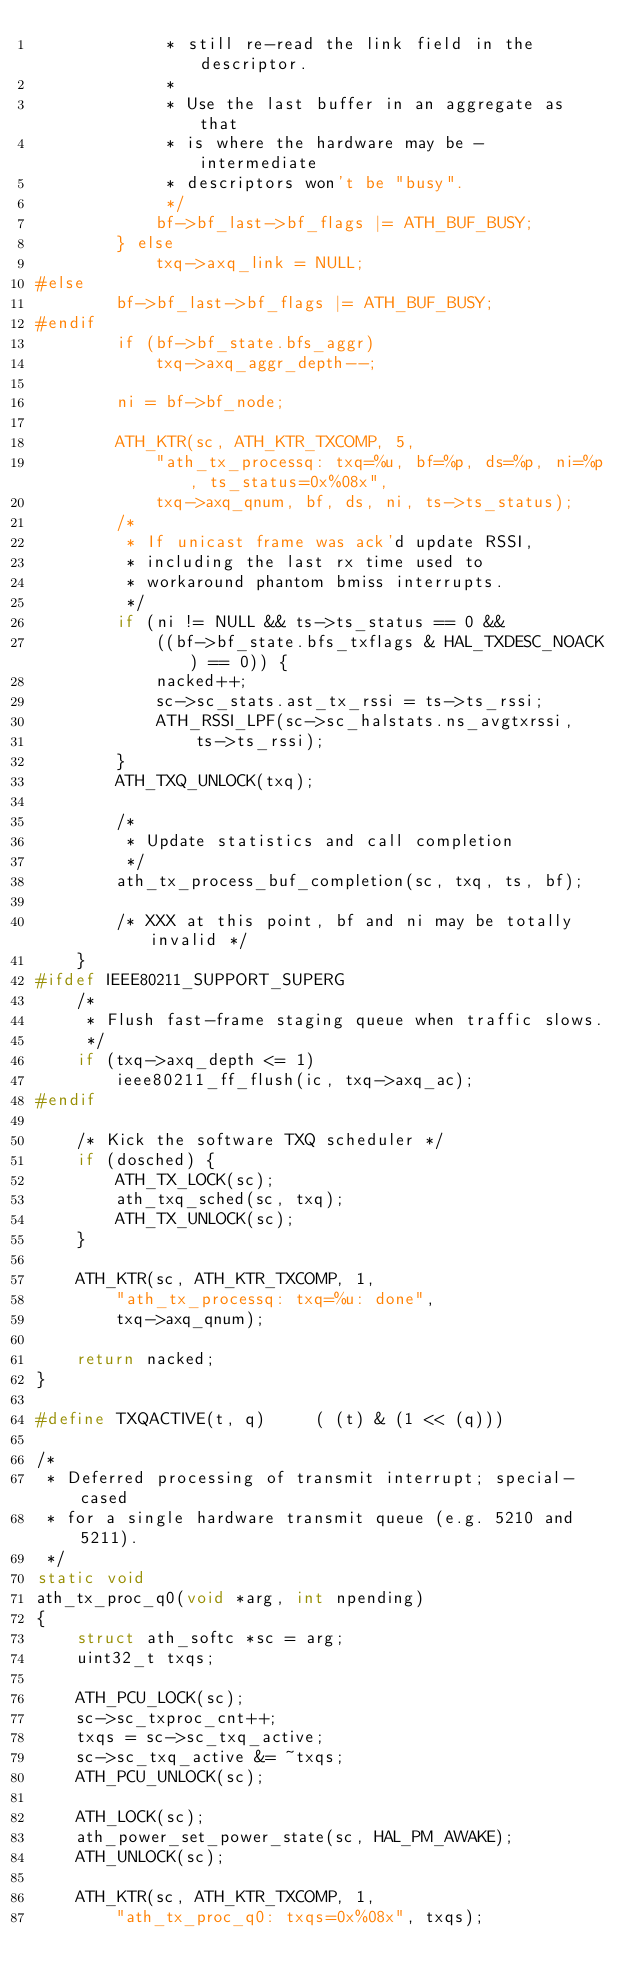Convert code to text. <code><loc_0><loc_0><loc_500><loc_500><_C_>			 * still re-read the link field in the descriptor.
			 *
			 * Use the last buffer in an aggregate as that
			 * is where the hardware may be - intermediate
			 * descriptors won't be "busy".
			 */
			bf->bf_last->bf_flags |= ATH_BUF_BUSY;
		} else
			txq->axq_link = NULL;
#else
		bf->bf_last->bf_flags |= ATH_BUF_BUSY;
#endif
		if (bf->bf_state.bfs_aggr)
			txq->axq_aggr_depth--;

		ni = bf->bf_node;

		ATH_KTR(sc, ATH_KTR_TXCOMP, 5,
		    "ath_tx_processq: txq=%u, bf=%p, ds=%p, ni=%p, ts_status=0x%08x",
		    txq->axq_qnum, bf, ds, ni, ts->ts_status);
		/*
		 * If unicast frame was ack'd update RSSI,
		 * including the last rx time used to
		 * workaround phantom bmiss interrupts.
		 */
		if (ni != NULL && ts->ts_status == 0 &&
		    ((bf->bf_state.bfs_txflags & HAL_TXDESC_NOACK) == 0)) {
			nacked++;
			sc->sc_stats.ast_tx_rssi = ts->ts_rssi;
			ATH_RSSI_LPF(sc->sc_halstats.ns_avgtxrssi,
				ts->ts_rssi);
		}
		ATH_TXQ_UNLOCK(txq);

		/*
		 * Update statistics and call completion
		 */
		ath_tx_process_buf_completion(sc, txq, ts, bf);

		/* XXX at this point, bf and ni may be totally invalid */
	}
#ifdef IEEE80211_SUPPORT_SUPERG
	/*
	 * Flush fast-frame staging queue when traffic slows.
	 */
	if (txq->axq_depth <= 1)
		ieee80211_ff_flush(ic, txq->axq_ac);
#endif

	/* Kick the software TXQ scheduler */
	if (dosched) {
		ATH_TX_LOCK(sc);
		ath_txq_sched(sc, txq);
		ATH_TX_UNLOCK(sc);
	}

	ATH_KTR(sc, ATH_KTR_TXCOMP, 1,
	    "ath_tx_processq: txq=%u: done",
	    txq->axq_qnum);

	return nacked;
}

#define	TXQACTIVE(t, q)		( (t) & (1 << (q)))

/*
 * Deferred processing of transmit interrupt; special-cased
 * for a single hardware transmit queue (e.g. 5210 and 5211).
 */
static void
ath_tx_proc_q0(void *arg, int npending)
{
	struct ath_softc *sc = arg;
	uint32_t txqs;

	ATH_PCU_LOCK(sc);
	sc->sc_txproc_cnt++;
	txqs = sc->sc_txq_active;
	sc->sc_txq_active &= ~txqs;
	ATH_PCU_UNLOCK(sc);

	ATH_LOCK(sc);
	ath_power_set_power_state(sc, HAL_PM_AWAKE);
	ATH_UNLOCK(sc);

	ATH_KTR(sc, ATH_KTR_TXCOMP, 1,
	    "ath_tx_proc_q0: txqs=0x%08x", txqs);
</code> 